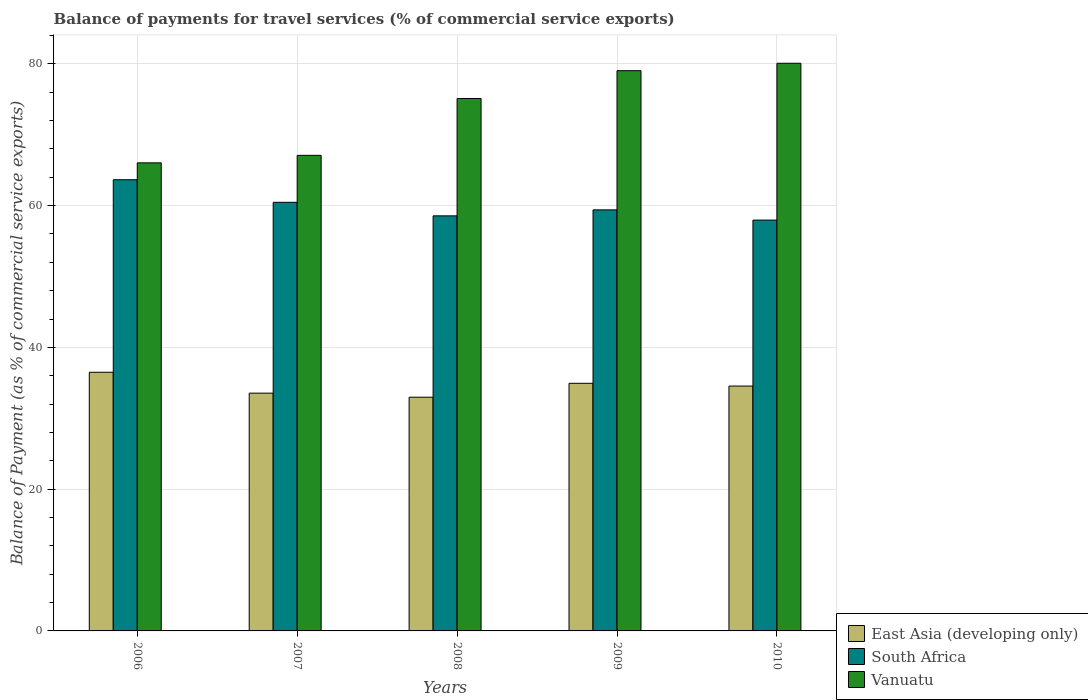Are the number of bars on each tick of the X-axis equal?
Give a very brief answer. Yes. How many bars are there on the 3rd tick from the right?
Give a very brief answer. 3. What is the label of the 1st group of bars from the left?
Offer a terse response. 2006. In how many cases, is the number of bars for a given year not equal to the number of legend labels?
Offer a very short reply. 0. What is the balance of payments for travel services in South Africa in 2008?
Offer a very short reply. 58.55. Across all years, what is the maximum balance of payments for travel services in South Africa?
Give a very brief answer. 63.65. Across all years, what is the minimum balance of payments for travel services in East Asia (developing only)?
Ensure brevity in your answer.  32.97. In which year was the balance of payments for travel services in Vanuatu minimum?
Offer a very short reply. 2006. What is the total balance of payments for travel services in East Asia (developing only) in the graph?
Provide a short and direct response. 172.47. What is the difference between the balance of payments for travel services in South Africa in 2006 and that in 2007?
Your response must be concise. 3.18. What is the difference between the balance of payments for travel services in Vanuatu in 2010 and the balance of payments for travel services in South Africa in 2009?
Make the answer very short. 20.68. What is the average balance of payments for travel services in South Africa per year?
Offer a very short reply. 60. In the year 2010, what is the difference between the balance of payments for travel services in Vanuatu and balance of payments for travel services in East Asia (developing only)?
Provide a short and direct response. 45.54. In how many years, is the balance of payments for travel services in Vanuatu greater than 76 %?
Give a very brief answer. 2. What is the ratio of the balance of payments for travel services in East Asia (developing only) in 2008 to that in 2010?
Provide a succinct answer. 0.95. What is the difference between the highest and the second highest balance of payments for travel services in Vanuatu?
Offer a terse response. 1.05. What is the difference between the highest and the lowest balance of payments for travel services in Vanuatu?
Ensure brevity in your answer.  14.05. In how many years, is the balance of payments for travel services in East Asia (developing only) greater than the average balance of payments for travel services in East Asia (developing only) taken over all years?
Provide a succinct answer. 3. Is the sum of the balance of payments for travel services in South Africa in 2006 and 2008 greater than the maximum balance of payments for travel services in East Asia (developing only) across all years?
Give a very brief answer. Yes. What does the 3rd bar from the left in 2007 represents?
Ensure brevity in your answer.  Vanuatu. What does the 1st bar from the right in 2007 represents?
Provide a short and direct response. Vanuatu. Is it the case that in every year, the sum of the balance of payments for travel services in Vanuatu and balance of payments for travel services in East Asia (developing only) is greater than the balance of payments for travel services in South Africa?
Keep it short and to the point. Yes. How many bars are there?
Give a very brief answer. 15. How many years are there in the graph?
Ensure brevity in your answer.  5. Does the graph contain any zero values?
Offer a very short reply. No. Does the graph contain grids?
Make the answer very short. Yes. How many legend labels are there?
Offer a terse response. 3. How are the legend labels stacked?
Give a very brief answer. Vertical. What is the title of the graph?
Ensure brevity in your answer.  Balance of payments for travel services (% of commercial service exports). What is the label or title of the X-axis?
Keep it short and to the point. Years. What is the label or title of the Y-axis?
Your answer should be very brief. Balance of Payment (as % of commercial service exports). What is the Balance of Payment (as % of commercial service exports) in East Asia (developing only) in 2006?
Provide a short and direct response. 36.49. What is the Balance of Payment (as % of commercial service exports) of South Africa in 2006?
Make the answer very short. 63.65. What is the Balance of Payment (as % of commercial service exports) of Vanuatu in 2006?
Your answer should be compact. 66.03. What is the Balance of Payment (as % of commercial service exports) of East Asia (developing only) in 2007?
Give a very brief answer. 33.54. What is the Balance of Payment (as % of commercial service exports) of South Africa in 2007?
Provide a short and direct response. 60.46. What is the Balance of Payment (as % of commercial service exports) of Vanuatu in 2007?
Your answer should be compact. 67.09. What is the Balance of Payment (as % of commercial service exports) in East Asia (developing only) in 2008?
Ensure brevity in your answer.  32.97. What is the Balance of Payment (as % of commercial service exports) in South Africa in 2008?
Your response must be concise. 58.55. What is the Balance of Payment (as % of commercial service exports) of Vanuatu in 2008?
Your answer should be very brief. 75.11. What is the Balance of Payment (as % of commercial service exports) of East Asia (developing only) in 2009?
Give a very brief answer. 34.93. What is the Balance of Payment (as % of commercial service exports) in South Africa in 2009?
Provide a succinct answer. 59.4. What is the Balance of Payment (as % of commercial service exports) of Vanuatu in 2009?
Provide a succinct answer. 79.03. What is the Balance of Payment (as % of commercial service exports) of East Asia (developing only) in 2010?
Offer a terse response. 34.54. What is the Balance of Payment (as % of commercial service exports) of South Africa in 2010?
Give a very brief answer. 57.95. What is the Balance of Payment (as % of commercial service exports) of Vanuatu in 2010?
Ensure brevity in your answer.  80.08. Across all years, what is the maximum Balance of Payment (as % of commercial service exports) of East Asia (developing only)?
Ensure brevity in your answer.  36.49. Across all years, what is the maximum Balance of Payment (as % of commercial service exports) in South Africa?
Give a very brief answer. 63.65. Across all years, what is the maximum Balance of Payment (as % of commercial service exports) of Vanuatu?
Your answer should be very brief. 80.08. Across all years, what is the minimum Balance of Payment (as % of commercial service exports) of East Asia (developing only)?
Offer a terse response. 32.97. Across all years, what is the minimum Balance of Payment (as % of commercial service exports) in South Africa?
Make the answer very short. 57.95. Across all years, what is the minimum Balance of Payment (as % of commercial service exports) of Vanuatu?
Your response must be concise. 66.03. What is the total Balance of Payment (as % of commercial service exports) of East Asia (developing only) in the graph?
Provide a succinct answer. 172.47. What is the total Balance of Payment (as % of commercial service exports) of South Africa in the graph?
Your response must be concise. 300.02. What is the total Balance of Payment (as % of commercial service exports) of Vanuatu in the graph?
Offer a terse response. 367.33. What is the difference between the Balance of Payment (as % of commercial service exports) in East Asia (developing only) in 2006 and that in 2007?
Provide a short and direct response. 2.95. What is the difference between the Balance of Payment (as % of commercial service exports) in South Africa in 2006 and that in 2007?
Provide a short and direct response. 3.18. What is the difference between the Balance of Payment (as % of commercial service exports) of Vanuatu in 2006 and that in 2007?
Make the answer very short. -1.06. What is the difference between the Balance of Payment (as % of commercial service exports) in East Asia (developing only) in 2006 and that in 2008?
Provide a succinct answer. 3.52. What is the difference between the Balance of Payment (as % of commercial service exports) in South Africa in 2006 and that in 2008?
Offer a very short reply. 5.1. What is the difference between the Balance of Payment (as % of commercial service exports) of Vanuatu in 2006 and that in 2008?
Keep it short and to the point. -9.08. What is the difference between the Balance of Payment (as % of commercial service exports) in East Asia (developing only) in 2006 and that in 2009?
Offer a terse response. 1.56. What is the difference between the Balance of Payment (as % of commercial service exports) of South Africa in 2006 and that in 2009?
Your answer should be very brief. 4.25. What is the difference between the Balance of Payment (as % of commercial service exports) in Vanuatu in 2006 and that in 2009?
Your answer should be very brief. -13. What is the difference between the Balance of Payment (as % of commercial service exports) of East Asia (developing only) in 2006 and that in 2010?
Offer a terse response. 1.95. What is the difference between the Balance of Payment (as % of commercial service exports) of South Africa in 2006 and that in 2010?
Offer a terse response. 5.7. What is the difference between the Balance of Payment (as % of commercial service exports) in Vanuatu in 2006 and that in 2010?
Make the answer very short. -14.05. What is the difference between the Balance of Payment (as % of commercial service exports) of East Asia (developing only) in 2007 and that in 2008?
Your answer should be very brief. 0.57. What is the difference between the Balance of Payment (as % of commercial service exports) of South Africa in 2007 and that in 2008?
Ensure brevity in your answer.  1.91. What is the difference between the Balance of Payment (as % of commercial service exports) of Vanuatu in 2007 and that in 2008?
Provide a short and direct response. -8.02. What is the difference between the Balance of Payment (as % of commercial service exports) in East Asia (developing only) in 2007 and that in 2009?
Offer a very short reply. -1.39. What is the difference between the Balance of Payment (as % of commercial service exports) in South Africa in 2007 and that in 2009?
Keep it short and to the point. 1.07. What is the difference between the Balance of Payment (as % of commercial service exports) in Vanuatu in 2007 and that in 2009?
Your response must be concise. -11.94. What is the difference between the Balance of Payment (as % of commercial service exports) in East Asia (developing only) in 2007 and that in 2010?
Ensure brevity in your answer.  -1. What is the difference between the Balance of Payment (as % of commercial service exports) in South Africa in 2007 and that in 2010?
Offer a terse response. 2.51. What is the difference between the Balance of Payment (as % of commercial service exports) of Vanuatu in 2007 and that in 2010?
Your answer should be compact. -12.99. What is the difference between the Balance of Payment (as % of commercial service exports) in East Asia (developing only) in 2008 and that in 2009?
Your response must be concise. -1.96. What is the difference between the Balance of Payment (as % of commercial service exports) in South Africa in 2008 and that in 2009?
Offer a very short reply. -0.84. What is the difference between the Balance of Payment (as % of commercial service exports) in Vanuatu in 2008 and that in 2009?
Offer a terse response. -3.92. What is the difference between the Balance of Payment (as % of commercial service exports) in East Asia (developing only) in 2008 and that in 2010?
Your answer should be compact. -1.57. What is the difference between the Balance of Payment (as % of commercial service exports) of South Africa in 2008 and that in 2010?
Offer a terse response. 0.6. What is the difference between the Balance of Payment (as % of commercial service exports) in Vanuatu in 2008 and that in 2010?
Your answer should be compact. -4.97. What is the difference between the Balance of Payment (as % of commercial service exports) in East Asia (developing only) in 2009 and that in 2010?
Give a very brief answer. 0.39. What is the difference between the Balance of Payment (as % of commercial service exports) in South Africa in 2009 and that in 2010?
Keep it short and to the point. 1.45. What is the difference between the Balance of Payment (as % of commercial service exports) in Vanuatu in 2009 and that in 2010?
Make the answer very short. -1.05. What is the difference between the Balance of Payment (as % of commercial service exports) of East Asia (developing only) in 2006 and the Balance of Payment (as % of commercial service exports) of South Africa in 2007?
Offer a very short reply. -23.97. What is the difference between the Balance of Payment (as % of commercial service exports) of East Asia (developing only) in 2006 and the Balance of Payment (as % of commercial service exports) of Vanuatu in 2007?
Provide a short and direct response. -30.6. What is the difference between the Balance of Payment (as % of commercial service exports) in South Africa in 2006 and the Balance of Payment (as % of commercial service exports) in Vanuatu in 2007?
Offer a terse response. -3.44. What is the difference between the Balance of Payment (as % of commercial service exports) in East Asia (developing only) in 2006 and the Balance of Payment (as % of commercial service exports) in South Africa in 2008?
Make the answer very short. -22.06. What is the difference between the Balance of Payment (as % of commercial service exports) of East Asia (developing only) in 2006 and the Balance of Payment (as % of commercial service exports) of Vanuatu in 2008?
Ensure brevity in your answer.  -38.62. What is the difference between the Balance of Payment (as % of commercial service exports) in South Africa in 2006 and the Balance of Payment (as % of commercial service exports) in Vanuatu in 2008?
Provide a short and direct response. -11.46. What is the difference between the Balance of Payment (as % of commercial service exports) in East Asia (developing only) in 2006 and the Balance of Payment (as % of commercial service exports) in South Africa in 2009?
Your answer should be very brief. -22.91. What is the difference between the Balance of Payment (as % of commercial service exports) of East Asia (developing only) in 2006 and the Balance of Payment (as % of commercial service exports) of Vanuatu in 2009?
Provide a succinct answer. -42.54. What is the difference between the Balance of Payment (as % of commercial service exports) in South Africa in 2006 and the Balance of Payment (as % of commercial service exports) in Vanuatu in 2009?
Give a very brief answer. -15.38. What is the difference between the Balance of Payment (as % of commercial service exports) in East Asia (developing only) in 2006 and the Balance of Payment (as % of commercial service exports) in South Africa in 2010?
Provide a short and direct response. -21.46. What is the difference between the Balance of Payment (as % of commercial service exports) of East Asia (developing only) in 2006 and the Balance of Payment (as % of commercial service exports) of Vanuatu in 2010?
Provide a succinct answer. -43.59. What is the difference between the Balance of Payment (as % of commercial service exports) in South Africa in 2006 and the Balance of Payment (as % of commercial service exports) in Vanuatu in 2010?
Provide a short and direct response. -16.43. What is the difference between the Balance of Payment (as % of commercial service exports) of East Asia (developing only) in 2007 and the Balance of Payment (as % of commercial service exports) of South Africa in 2008?
Make the answer very short. -25.01. What is the difference between the Balance of Payment (as % of commercial service exports) in East Asia (developing only) in 2007 and the Balance of Payment (as % of commercial service exports) in Vanuatu in 2008?
Make the answer very short. -41.56. What is the difference between the Balance of Payment (as % of commercial service exports) in South Africa in 2007 and the Balance of Payment (as % of commercial service exports) in Vanuatu in 2008?
Your answer should be compact. -14.64. What is the difference between the Balance of Payment (as % of commercial service exports) of East Asia (developing only) in 2007 and the Balance of Payment (as % of commercial service exports) of South Africa in 2009?
Provide a succinct answer. -25.86. What is the difference between the Balance of Payment (as % of commercial service exports) of East Asia (developing only) in 2007 and the Balance of Payment (as % of commercial service exports) of Vanuatu in 2009?
Provide a short and direct response. -45.49. What is the difference between the Balance of Payment (as % of commercial service exports) in South Africa in 2007 and the Balance of Payment (as % of commercial service exports) in Vanuatu in 2009?
Your response must be concise. -18.57. What is the difference between the Balance of Payment (as % of commercial service exports) of East Asia (developing only) in 2007 and the Balance of Payment (as % of commercial service exports) of South Africa in 2010?
Your answer should be compact. -24.41. What is the difference between the Balance of Payment (as % of commercial service exports) of East Asia (developing only) in 2007 and the Balance of Payment (as % of commercial service exports) of Vanuatu in 2010?
Provide a short and direct response. -46.54. What is the difference between the Balance of Payment (as % of commercial service exports) in South Africa in 2007 and the Balance of Payment (as % of commercial service exports) in Vanuatu in 2010?
Provide a succinct answer. -19.61. What is the difference between the Balance of Payment (as % of commercial service exports) in East Asia (developing only) in 2008 and the Balance of Payment (as % of commercial service exports) in South Africa in 2009?
Provide a succinct answer. -26.43. What is the difference between the Balance of Payment (as % of commercial service exports) of East Asia (developing only) in 2008 and the Balance of Payment (as % of commercial service exports) of Vanuatu in 2009?
Offer a very short reply. -46.06. What is the difference between the Balance of Payment (as % of commercial service exports) in South Africa in 2008 and the Balance of Payment (as % of commercial service exports) in Vanuatu in 2009?
Provide a succinct answer. -20.48. What is the difference between the Balance of Payment (as % of commercial service exports) in East Asia (developing only) in 2008 and the Balance of Payment (as % of commercial service exports) in South Africa in 2010?
Ensure brevity in your answer.  -24.98. What is the difference between the Balance of Payment (as % of commercial service exports) of East Asia (developing only) in 2008 and the Balance of Payment (as % of commercial service exports) of Vanuatu in 2010?
Your answer should be very brief. -47.11. What is the difference between the Balance of Payment (as % of commercial service exports) in South Africa in 2008 and the Balance of Payment (as % of commercial service exports) in Vanuatu in 2010?
Keep it short and to the point. -21.53. What is the difference between the Balance of Payment (as % of commercial service exports) in East Asia (developing only) in 2009 and the Balance of Payment (as % of commercial service exports) in South Africa in 2010?
Keep it short and to the point. -23.02. What is the difference between the Balance of Payment (as % of commercial service exports) of East Asia (developing only) in 2009 and the Balance of Payment (as % of commercial service exports) of Vanuatu in 2010?
Offer a very short reply. -45.15. What is the difference between the Balance of Payment (as % of commercial service exports) of South Africa in 2009 and the Balance of Payment (as % of commercial service exports) of Vanuatu in 2010?
Ensure brevity in your answer.  -20.68. What is the average Balance of Payment (as % of commercial service exports) in East Asia (developing only) per year?
Offer a terse response. 34.49. What is the average Balance of Payment (as % of commercial service exports) in South Africa per year?
Give a very brief answer. 60. What is the average Balance of Payment (as % of commercial service exports) of Vanuatu per year?
Ensure brevity in your answer.  73.47. In the year 2006, what is the difference between the Balance of Payment (as % of commercial service exports) in East Asia (developing only) and Balance of Payment (as % of commercial service exports) in South Africa?
Ensure brevity in your answer.  -27.16. In the year 2006, what is the difference between the Balance of Payment (as % of commercial service exports) of East Asia (developing only) and Balance of Payment (as % of commercial service exports) of Vanuatu?
Make the answer very short. -29.54. In the year 2006, what is the difference between the Balance of Payment (as % of commercial service exports) in South Africa and Balance of Payment (as % of commercial service exports) in Vanuatu?
Offer a terse response. -2.38. In the year 2007, what is the difference between the Balance of Payment (as % of commercial service exports) in East Asia (developing only) and Balance of Payment (as % of commercial service exports) in South Africa?
Provide a short and direct response. -26.92. In the year 2007, what is the difference between the Balance of Payment (as % of commercial service exports) in East Asia (developing only) and Balance of Payment (as % of commercial service exports) in Vanuatu?
Offer a terse response. -33.55. In the year 2007, what is the difference between the Balance of Payment (as % of commercial service exports) of South Africa and Balance of Payment (as % of commercial service exports) of Vanuatu?
Give a very brief answer. -6.63. In the year 2008, what is the difference between the Balance of Payment (as % of commercial service exports) of East Asia (developing only) and Balance of Payment (as % of commercial service exports) of South Africa?
Provide a short and direct response. -25.58. In the year 2008, what is the difference between the Balance of Payment (as % of commercial service exports) in East Asia (developing only) and Balance of Payment (as % of commercial service exports) in Vanuatu?
Your answer should be very brief. -42.14. In the year 2008, what is the difference between the Balance of Payment (as % of commercial service exports) of South Africa and Balance of Payment (as % of commercial service exports) of Vanuatu?
Offer a very short reply. -16.55. In the year 2009, what is the difference between the Balance of Payment (as % of commercial service exports) of East Asia (developing only) and Balance of Payment (as % of commercial service exports) of South Africa?
Make the answer very short. -24.47. In the year 2009, what is the difference between the Balance of Payment (as % of commercial service exports) in East Asia (developing only) and Balance of Payment (as % of commercial service exports) in Vanuatu?
Ensure brevity in your answer.  -44.1. In the year 2009, what is the difference between the Balance of Payment (as % of commercial service exports) in South Africa and Balance of Payment (as % of commercial service exports) in Vanuatu?
Your answer should be compact. -19.63. In the year 2010, what is the difference between the Balance of Payment (as % of commercial service exports) in East Asia (developing only) and Balance of Payment (as % of commercial service exports) in South Africa?
Your answer should be very brief. -23.41. In the year 2010, what is the difference between the Balance of Payment (as % of commercial service exports) in East Asia (developing only) and Balance of Payment (as % of commercial service exports) in Vanuatu?
Offer a terse response. -45.54. In the year 2010, what is the difference between the Balance of Payment (as % of commercial service exports) in South Africa and Balance of Payment (as % of commercial service exports) in Vanuatu?
Provide a short and direct response. -22.13. What is the ratio of the Balance of Payment (as % of commercial service exports) of East Asia (developing only) in 2006 to that in 2007?
Make the answer very short. 1.09. What is the ratio of the Balance of Payment (as % of commercial service exports) in South Africa in 2006 to that in 2007?
Ensure brevity in your answer.  1.05. What is the ratio of the Balance of Payment (as % of commercial service exports) of Vanuatu in 2006 to that in 2007?
Provide a succinct answer. 0.98. What is the ratio of the Balance of Payment (as % of commercial service exports) in East Asia (developing only) in 2006 to that in 2008?
Your answer should be compact. 1.11. What is the ratio of the Balance of Payment (as % of commercial service exports) in South Africa in 2006 to that in 2008?
Offer a terse response. 1.09. What is the ratio of the Balance of Payment (as % of commercial service exports) of Vanuatu in 2006 to that in 2008?
Give a very brief answer. 0.88. What is the ratio of the Balance of Payment (as % of commercial service exports) of East Asia (developing only) in 2006 to that in 2009?
Your response must be concise. 1.04. What is the ratio of the Balance of Payment (as % of commercial service exports) of South Africa in 2006 to that in 2009?
Give a very brief answer. 1.07. What is the ratio of the Balance of Payment (as % of commercial service exports) in Vanuatu in 2006 to that in 2009?
Give a very brief answer. 0.84. What is the ratio of the Balance of Payment (as % of commercial service exports) in East Asia (developing only) in 2006 to that in 2010?
Offer a terse response. 1.06. What is the ratio of the Balance of Payment (as % of commercial service exports) of South Africa in 2006 to that in 2010?
Make the answer very short. 1.1. What is the ratio of the Balance of Payment (as % of commercial service exports) of Vanuatu in 2006 to that in 2010?
Keep it short and to the point. 0.82. What is the ratio of the Balance of Payment (as % of commercial service exports) of East Asia (developing only) in 2007 to that in 2008?
Offer a very short reply. 1.02. What is the ratio of the Balance of Payment (as % of commercial service exports) of South Africa in 2007 to that in 2008?
Ensure brevity in your answer.  1.03. What is the ratio of the Balance of Payment (as % of commercial service exports) of Vanuatu in 2007 to that in 2008?
Give a very brief answer. 0.89. What is the ratio of the Balance of Payment (as % of commercial service exports) of East Asia (developing only) in 2007 to that in 2009?
Make the answer very short. 0.96. What is the ratio of the Balance of Payment (as % of commercial service exports) in South Africa in 2007 to that in 2009?
Your answer should be compact. 1.02. What is the ratio of the Balance of Payment (as % of commercial service exports) of Vanuatu in 2007 to that in 2009?
Your answer should be compact. 0.85. What is the ratio of the Balance of Payment (as % of commercial service exports) in East Asia (developing only) in 2007 to that in 2010?
Provide a succinct answer. 0.97. What is the ratio of the Balance of Payment (as % of commercial service exports) in South Africa in 2007 to that in 2010?
Make the answer very short. 1.04. What is the ratio of the Balance of Payment (as % of commercial service exports) in Vanuatu in 2007 to that in 2010?
Your response must be concise. 0.84. What is the ratio of the Balance of Payment (as % of commercial service exports) in East Asia (developing only) in 2008 to that in 2009?
Your answer should be compact. 0.94. What is the ratio of the Balance of Payment (as % of commercial service exports) of South Africa in 2008 to that in 2009?
Ensure brevity in your answer.  0.99. What is the ratio of the Balance of Payment (as % of commercial service exports) of Vanuatu in 2008 to that in 2009?
Keep it short and to the point. 0.95. What is the ratio of the Balance of Payment (as % of commercial service exports) in East Asia (developing only) in 2008 to that in 2010?
Provide a short and direct response. 0.95. What is the ratio of the Balance of Payment (as % of commercial service exports) of South Africa in 2008 to that in 2010?
Ensure brevity in your answer.  1.01. What is the ratio of the Balance of Payment (as % of commercial service exports) of Vanuatu in 2008 to that in 2010?
Offer a terse response. 0.94. What is the ratio of the Balance of Payment (as % of commercial service exports) of East Asia (developing only) in 2009 to that in 2010?
Offer a terse response. 1.01. What is the ratio of the Balance of Payment (as % of commercial service exports) of South Africa in 2009 to that in 2010?
Offer a very short reply. 1.02. What is the ratio of the Balance of Payment (as % of commercial service exports) of Vanuatu in 2009 to that in 2010?
Your answer should be compact. 0.99. What is the difference between the highest and the second highest Balance of Payment (as % of commercial service exports) of East Asia (developing only)?
Ensure brevity in your answer.  1.56. What is the difference between the highest and the second highest Balance of Payment (as % of commercial service exports) in South Africa?
Offer a terse response. 3.18. What is the difference between the highest and the second highest Balance of Payment (as % of commercial service exports) in Vanuatu?
Ensure brevity in your answer.  1.05. What is the difference between the highest and the lowest Balance of Payment (as % of commercial service exports) of East Asia (developing only)?
Your response must be concise. 3.52. What is the difference between the highest and the lowest Balance of Payment (as % of commercial service exports) of South Africa?
Offer a very short reply. 5.7. What is the difference between the highest and the lowest Balance of Payment (as % of commercial service exports) in Vanuatu?
Ensure brevity in your answer.  14.05. 